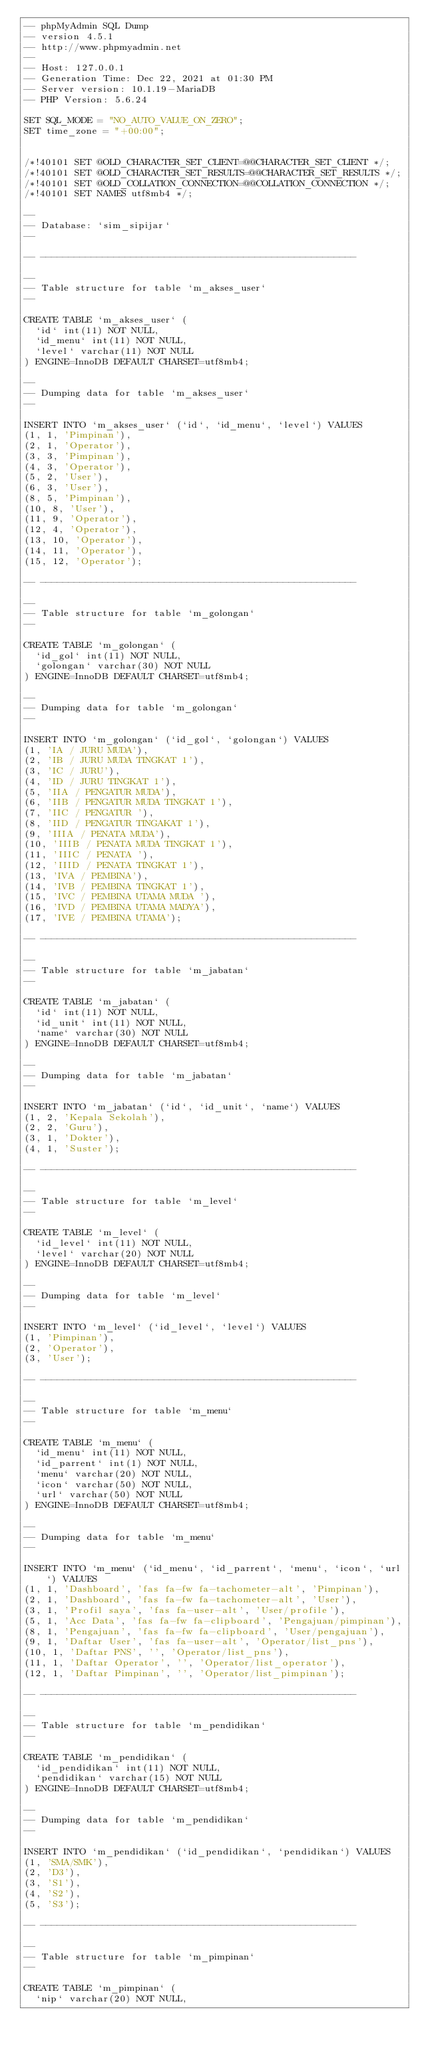Convert code to text. <code><loc_0><loc_0><loc_500><loc_500><_SQL_>-- phpMyAdmin SQL Dump
-- version 4.5.1
-- http://www.phpmyadmin.net
--
-- Host: 127.0.0.1
-- Generation Time: Dec 22, 2021 at 01:30 PM
-- Server version: 10.1.19-MariaDB
-- PHP Version: 5.6.24

SET SQL_MODE = "NO_AUTO_VALUE_ON_ZERO";
SET time_zone = "+00:00";


/*!40101 SET @OLD_CHARACTER_SET_CLIENT=@@CHARACTER_SET_CLIENT */;
/*!40101 SET @OLD_CHARACTER_SET_RESULTS=@@CHARACTER_SET_RESULTS */;
/*!40101 SET @OLD_COLLATION_CONNECTION=@@COLLATION_CONNECTION */;
/*!40101 SET NAMES utf8mb4 */;

--
-- Database: `sim_sipijar`
--

-- --------------------------------------------------------

--
-- Table structure for table `m_akses_user`
--

CREATE TABLE `m_akses_user` (
  `id` int(11) NOT NULL,
  `id_menu` int(11) NOT NULL,
  `level` varchar(11) NOT NULL
) ENGINE=InnoDB DEFAULT CHARSET=utf8mb4;

--
-- Dumping data for table `m_akses_user`
--

INSERT INTO `m_akses_user` (`id`, `id_menu`, `level`) VALUES
(1, 1, 'Pimpinan'),
(2, 1, 'Operator'),
(3, 3, 'Pimpinan'),
(4, 3, 'Operator'),
(5, 2, 'User'),
(6, 3, 'User'),
(8, 5, 'Pimpinan'),
(10, 8, 'User'),
(11, 9, 'Operator'),
(12, 4, 'Operator'),
(13, 10, 'Operator'),
(14, 11, 'Operator'),
(15, 12, 'Operator');

-- --------------------------------------------------------

--
-- Table structure for table `m_golongan`
--

CREATE TABLE `m_golongan` (
  `id_gol` int(11) NOT NULL,
  `golongan` varchar(30) NOT NULL
) ENGINE=InnoDB DEFAULT CHARSET=utf8mb4;

--
-- Dumping data for table `m_golongan`
--

INSERT INTO `m_golongan` (`id_gol`, `golongan`) VALUES
(1, 'IA / JURU MUDA'),
(2, 'IB / JURU MUDA TINGKAT 1'),
(3, 'IC / JURU'),
(4, 'ID / JURU TINGKAT 1'),
(5, 'IIA / PENGATUR MUDA'),
(6, 'IIB / PENGATUR MUDA TINGKAT 1'),
(7, 'IIC / PENGATUR '),
(8, 'IID / PENGATUR TINGAKAT 1'),
(9, 'IIIA / PENATA MUDA'),
(10, 'IIIB / PENATA MUDA TINGKAT 1'),
(11, 'IIIC / PENATA '),
(12, 'IIID / PENATA TINGKAT 1'),
(13, 'IVA / PEMBINA'),
(14, 'IVB / PEMBINA TINGKAT 1'),
(15, 'IVC / PEMBINA UTAMA MUDA '),
(16, 'IVD / PEMBINA UTAMA MADYA'),
(17, 'IVE / PEMBINA UTAMA');

-- --------------------------------------------------------

--
-- Table structure for table `m_jabatan`
--

CREATE TABLE `m_jabatan` (
  `id` int(11) NOT NULL,
  `id_unit` int(11) NOT NULL,
  `name` varchar(30) NOT NULL
) ENGINE=InnoDB DEFAULT CHARSET=utf8mb4;

--
-- Dumping data for table `m_jabatan`
--

INSERT INTO `m_jabatan` (`id`, `id_unit`, `name`) VALUES
(1, 2, 'Kepala Sekolah'),
(2, 2, 'Guru'),
(3, 1, 'Dokter'),
(4, 1, 'Suster');

-- --------------------------------------------------------

--
-- Table structure for table `m_level`
--

CREATE TABLE `m_level` (
  `id_level` int(11) NOT NULL,
  `level` varchar(20) NOT NULL
) ENGINE=InnoDB DEFAULT CHARSET=utf8mb4;

--
-- Dumping data for table `m_level`
--

INSERT INTO `m_level` (`id_level`, `level`) VALUES
(1, 'Pimpinan'),
(2, 'Operator'),
(3, 'User');

-- --------------------------------------------------------

--
-- Table structure for table `m_menu`
--

CREATE TABLE `m_menu` (
  `id_menu` int(11) NOT NULL,
  `id_parrent` int(1) NOT NULL,
  `menu` varchar(20) NOT NULL,
  `icon` varchar(50) NOT NULL,
  `url` varchar(50) NOT NULL
) ENGINE=InnoDB DEFAULT CHARSET=utf8mb4;

--
-- Dumping data for table `m_menu`
--

INSERT INTO `m_menu` (`id_menu`, `id_parrent`, `menu`, `icon`, `url`) VALUES
(1, 1, 'Dashboard', 'fas fa-fw fa-tachometer-alt', 'Pimpinan'),
(2, 1, 'Dashboard', 'fas fa-fw fa-tachometer-alt', 'User'),
(3, 1, 'Profil saya', 'fas fa-user-alt', 'User/profile'),
(5, 1, 'Acc Data', 'fas fa-fw fa-clipboard', 'Pengajuan/pimpinan'),
(8, 1, 'Pengajuan', 'fas fa-fw fa-clipboard', 'User/pengajuan'),
(9, 1, 'Daftar User', 'fas fa-user-alt', 'Operator/list_pns'),
(10, 1, 'Daftar PNS', '', 'Operator/list_pns'),
(11, 1, 'Daftar Operator', '', 'Operator/list_operator'),
(12, 1, 'Daftar Pimpinan', '', 'Operator/list_pimpinan');

-- --------------------------------------------------------

--
-- Table structure for table `m_pendidikan`
--

CREATE TABLE `m_pendidikan` (
  `id_pendidikan` int(11) NOT NULL,
  `pendidikan` varchar(15) NOT NULL
) ENGINE=InnoDB DEFAULT CHARSET=utf8mb4;

--
-- Dumping data for table `m_pendidikan`
--

INSERT INTO `m_pendidikan` (`id_pendidikan`, `pendidikan`) VALUES
(1, 'SMA/SMK'),
(2, 'D3'),
(3, 'S1'),
(4, 'S2'),
(5, 'S3');

-- --------------------------------------------------------

--
-- Table structure for table `m_pimpinan`
--

CREATE TABLE `m_pimpinan` (
  `nip` varchar(20) NOT NULL,</code> 